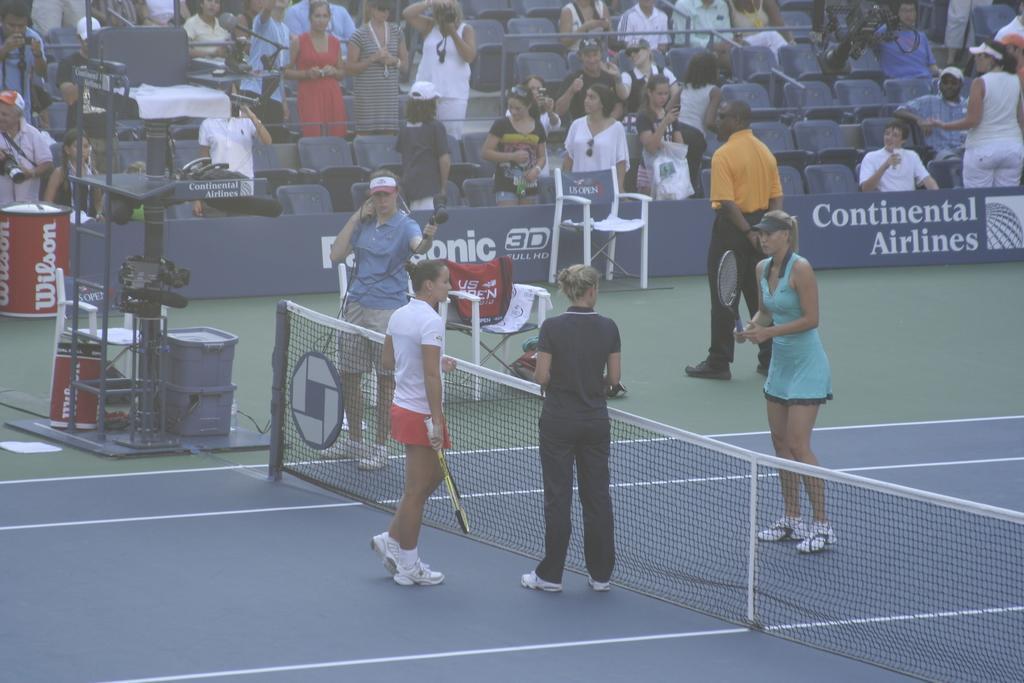Can you describe this image briefly? In this image 2 woman are standing and holding a tennis racket and at the back ground there are group of people standing and some group of people are sitting in chairs , there is chair, hoarding, camera. 